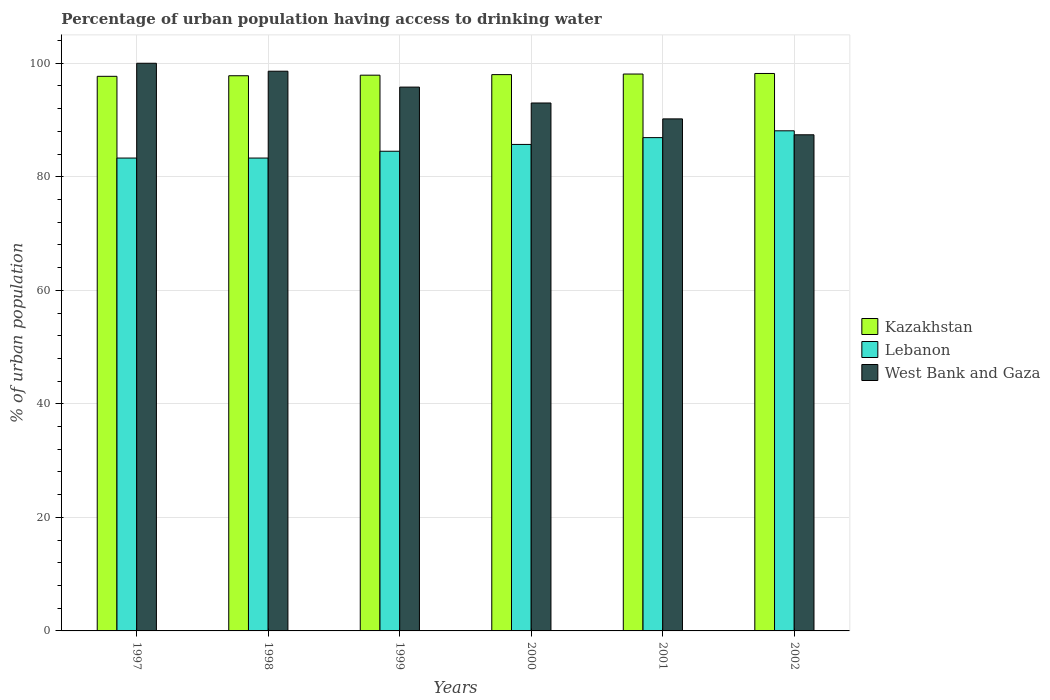Are the number of bars per tick equal to the number of legend labels?
Your answer should be compact. Yes. Are the number of bars on each tick of the X-axis equal?
Offer a terse response. Yes. How many bars are there on the 5th tick from the left?
Keep it short and to the point. 3. What is the label of the 4th group of bars from the left?
Ensure brevity in your answer.  2000. In how many cases, is the number of bars for a given year not equal to the number of legend labels?
Provide a short and direct response. 0. What is the percentage of urban population having access to drinking water in Lebanon in 2000?
Keep it short and to the point. 85.7. Across all years, what is the maximum percentage of urban population having access to drinking water in West Bank and Gaza?
Your answer should be compact. 100. Across all years, what is the minimum percentage of urban population having access to drinking water in Lebanon?
Your answer should be compact. 83.3. In which year was the percentage of urban population having access to drinking water in Lebanon maximum?
Ensure brevity in your answer.  2002. In which year was the percentage of urban population having access to drinking water in Kazakhstan minimum?
Your answer should be compact. 1997. What is the total percentage of urban population having access to drinking water in Kazakhstan in the graph?
Provide a short and direct response. 587.7. What is the difference between the percentage of urban population having access to drinking water in Kazakhstan in 2001 and that in 2002?
Your answer should be very brief. -0.1. What is the average percentage of urban population having access to drinking water in Kazakhstan per year?
Provide a short and direct response. 97.95. In the year 1999, what is the difference between the percentage of urban population having access to drinking water in Lebanon and percentage of urban population having access to drinking water in West Bank and Gaza?
Your response must be concise. -11.3. In how many years, is the percentage of urban population having access to drinking water in Kazakhstan greater than 100 %?
Keep it short and to the point. 0. What is the ratio of the percentage of urban population having access to drinking water in Kazakhstan in 2001 to that in 2002?
Provide a short and direct response. 1. Is the percentage of urban population having access to drinking water in West Bank and Gaza in 1999 less than that in 2002?
Keep it short and to the point. No. Is the difference between the percentage of urban population having access to drinking water in Lebanon in 1999 and 2000 greater than the difference between the percentage of urban population having access to drinking water in West Bank and Gaza in 1999 and 2000?
Your answer should be compact. No. What is the difference between the highest and the second highest percentage of urban population having access to drinking water in Kazakhstan?
Give a very brief answer. 0.1. What is the difference between the highest and the lowest percentage of urban population having access to drinking water in Kazakhstan?
Offer a terse response. 0.5. In how many years, is the percentage of urban population having access to drinking water in Kazakhstan greater than the average percentage of urban population having access to drinking water in Kazakhstan taken over all years?
Make the answer very short. 3. What does the 2nd bar from the left in 1998 represents?
Ensure brevity in your answer.  Lebanon. What does the 2nd bar from the right in 1998 represents?
Provide a succinct answer. Lebanon. Is it the case that in every year, the sum of the percentage of urban population having access to drinking water in Lebanon and percentage of urban population having access to drinking water in Kazakhstan is greater than the percentage of urban population having access to drinking water in West Bank and Gaza?
Offer a very short reply. Yes. How many bars are there?
Ensure brevity in your answer.  18. How many years are there in the graph?
Give a very brief answer. 6. Does the graph contain any zero values?
Provide a succinct answer. No. Does the graph contain grids?
Keep it short and to the point. Yes. Where does the legend appear in the graph?
Keep it short and to the point. Center right. How are the legend labels stacked?
Your answer should be compact. Vertical. What is the title of the graph?
Make the answer very short. Percentage of urban population having access to drinking water. What is the label or title of the Y-axis?
Your answer should be very brief. % of urban population. What is the % of urban population of Kazakhstan in 1997?
Your response must be concise. 97.7. What is the % of urban population in Lebanon in 1997?
Your response must be concise. 83.3. What is the % of urban population of West Bank and Gaza in 1997?
Ensure brevity in your answer.  100. What is the % of urban population in Kazakhstan in 1998?
Your response must be concise. 97.8. What is the % of urban population of Lebanon in 1998?
Your answer should be compact. 83.3. What is the % of urban population in West Bank and Gaza in 1998?
Make the answer very short. 98.6. What is the % of urban population in Kazakhstan in 1999?
Provide a short and direct response. 97.9. What is the % of urban population of Lebanon in 1999?
Your answer should be compact. 84.5. What is the % of urban population of West Bank and Gaza in 1999?
Give a very brief answer. 95.8. What is the % of urban population in Kazakhstan in 2000?
Offer a terse response. 98. What is the % of urban population of Lebanon in 2000?
Provide a short and direct response. 85.7. What is the % of urban population of West Bank and Gaza in 2000?
Your answer should be compact. 93. What is the % of urban population of Kazakhstan in 2001?
Ensure brevity in your answer.  98.1. What is the % of urban population of Lebanon in 2001?
Keep it short and to the point. 86.9. What is the % of urban population in West Bank and Gaza in 2001?
Provide a succinct answer. 90.2. What is the % of urban population in Kazakhstan in 2002?
Your response must be concise. 98.2. What is the % of urban population of Lebanon in 2002?
Make the answer very short. 88.1. What is the % of urban population of West Bank and Gaza in 2002?
Give a very brief answer. 87.4. Across all years, what is the maximum % of urban population in Kazakhstan?
Provide a short and direct response. 98.2. Across all years, what is the maximum % of urban population of Lebanon?
Give a very brief answer. 88.1. Across all years, what is the minimum % of urban population in Kazakhstan?
Offer a terse response. 97.7. Across all years, what is the minimum % of urban population of Lebanon?
Provide a succinct answer. 83.3. Across all years, what is the minimum % of urban population of West Bank and Gaza?
Your response must be concise. 87.4. What is the total % of urban population of Kazakhstan in the graph?
Ensure brevity in your answer.  587.7. What is the total % of urban population of Lebanon in the graph?
Give a very brief answer. 511.8. What is the total % of urban population of West Bank and Gaza in the graph?
Provide a short and direct response. 565. What is the difference between the % of urban population of Kazakhstan in 1997 and that in 1998?
Offer a terse response. -0.1. What is the difference between the % of urban population in Lebanon in 1997 and that in 1998?
Provide a short and direct response. 0. What is the difference between the % of urban population in West Bank and Gaza in 1997 and that in 1998?
Your response must be concise. 1.4. What is the difference between the % of urban population in Lebanon in 1997 and that in 1999?
Offer a terse response. -1.2. What is the difference between the % of urban population of Kazakhstan in 1997 and that in 2000?
Keep it short and to the point. -0.3. What is the difference between the % of urban population of West Bank and Gaza in 1998 and that in 1999?
Provide a short and direct response. 2.8. What is the difference between the % of urban population of Kazakhstan in 1998 and that in 2002?
Give a very brief answer. -0.4. What is the difference between the % of urban population of Lebanon in 1998 and that in 2002?
Provide a succinct answer. -4.8. What is the difference between the % of urban population in Kazakhstan in 1999 and that in 2000?
Make the answer very short. -0.1. What is the difference between the % of urban population of Lebanon in 1999 and that in 2000?
Offer a terse response. -1.2. What is the difference between the % of urban population in West Bank and Gaza in 1999 and that in 2000?
Provide a succinct answer. 2.8. What is the difference between the % of urban population of Kazakhstan in 1999 and that in 2001?
Your response must be concise. -0.2. What is the difference between the % of urban population in Kazakhstan in 1999 and that in 2002?
Offer a very short reply. -0.3. What is the difference between the % of urban population in West Bank and Gaza in 1999 and that in 2002?
Offer a very short reply. 8.4. What is the difference between the % of urban population in Lebanon in 2000 and that in 2001?
Give a very brief answer. -1.2. What is the difference between the % of urban population in Kazakhstan in 2000 and that in 2002?
Your response must be concise. -0.2. What is the difference between the % of urban population of Lebanon in 2000 and that in 2002?
Offer a terse response. -2.4. What is the difference between the % of urban population in Kazakhstan in 2001 and that in 2002?
Provide a succinct answer. -0.1. What is the difference between the % of urban population in Lebanon in 1997 and the % of urban population in West Bank and Gaza in 1998?
Keep it short and to the point. -15.3. What is the difference between the % of urban population of Lebanon in 1997 and the % of urban population of West Bank and Gaza in 1999?
Ensure brevity in your answer.  -12.5. What is the difference between the % of urban population in Kazakhstan in 1997 and the % of urban population in West Bank and Gaza in 2000?
Your answer should be very brief. 4.7. What is the difference between the % of urban population in Kazakhstan in 1997 and the % of urban population in Lebanon in 2001?
Give a very brief answer. 10.8. What is the difference between the % of urban population in Kazakhstan in 1997 and the % of urban population in West Bank and Gaza in 2001?
Your answer should be compact. 7.5. What is the difference between the % of urban population in Lebanon in 1997 and the % of urban population in West Bank and Gaza in 2001?
Ensure brevity in your answer.  -6.9. What is the difference between the % of urban population of Kazakhstan in 1997 and the % of urban population of Lebanon in 2002?
Keep it short and to the point. 9.6. What is the difference between the % of urban population in Kazakhstan in 1997 and the % of urban population in West Bank and Gaza in 2002?
Ensure brevity in your answer.  10.3. What is the difference between the % of urban population of Lebanon in 1997 and the % of urban population of West Bank and Gaza in 2002?
Ensure brevity in your answer.  -4.1. What is the difference between the % of urban population in Kazakhstan in 1998 and the % of urban population in West Bank and Gaza in 2001?
Offer a very short reply. 7.6. What is the difference between the % of urban population of Lebanon in 1998 and the % of urban population of West Bank and Gaza in 2002?
Make the answer very short. -4.1. What is the difference between the % of urban population of Kazakhstan in 1999 and the % of urban population of West Bank and Gaza in 2000?
Provide a succinct answer. 4.9. What is the difference between the % of urban population of Lebanon in 1999 and the % of urban population of West Bank and Gaza in 2000?
Make the answer very short. -8.5. What is the difference between the % of urban population of Kazakhstan in 1999 and the % of urban population of Lebanon in 2001?
Offer a terse response. 11. What is the difference between the % of urban population in Kazakhstan in 1999 and the % of urban population in West Bank and Gaza in 2001?
Keep it short and to the point. 7.7. What is the difference between the % of urban population of Lebanon in 1999 and the % of urban population of West Bank and Gaza in 2002?
Your answer should be compact. -2.9. What is the difference between the % of urban population in Lebanon in 2000 and the % of urban population in West Bank and Gaza in 2001?
Offer a very short reply. -4.5. What is the difference between the % of urban population of Kazakhstan in 2000 and the % of urban population of Lebanon in 2002?
Offer a very short reply. 9.9. What is the difference between the % of urban population in Kazakhstan in 2000 and the % of urban population in West Bank and Gaza in 2002?
Make the answer very short. 10.6. What is the difference between the % of urban population of Lebanon in 2001 and the % of urban population of West Bank and Gaza in 2002?
Your answer should be compact. -0.5. What is the average % of urban population in Kazakhstan per year?
Offer a very short reply. 97.95. What is the average % of urban population in Lebanon per year?
Your answer should be very brief. 85.3. What is the average % of urban population in West Bank and Gaza per year?
Provide a succinct answer. 94.17. In the year 1997, what is the difference between the % of urban population of Kazakhstan and % of urban population of Lebanon?
Your response must be concise. 14.4. In the year 1997, what is the difference between the % of urban population in Lebanon and % of urban population in West Bank and Gaza?
Your answer should be compact. -16.7. In the year 1998, what is the difference between the % of urban population of Kazakhstan and % of urban population of Lebanon?
Provide a succinct answer. 14.5. In the year 1998, what is the difference between the % of urban population in Lebanon and % of urban population in West Bank and Gaza?
Ensure brevity in your answer.  -15.3. In the year 1999, what is the difference between the % of urban population of Kazakhstan and % of urban population of Lebanon?
Give a very brief answer. 13.4. In the year 1999, what is the difference between the % of urban population in Kazakhstan and % of urban population in West Bank and Gaza?
Provide a short and direct response. 2.1. In the year 1999, what is the difference between the % of urban population of Lebanon and % of urban population of West Bank and Gaza?
Ensure brevity in your answer.  -11.3. In the year 2000, what is the difference between the % of urban population in Kazakhstan and % of urban population in Lebanon?
Give a very brief answer. 12.3. In the year 2001, what is the difference between the % of urban population in Kazakhstan and % of urban population in Lebanon?
Provide a succinct answer. 11.2. In the year 2001, what is the difference between the % of urban population of Lebanon and % of urban population of West Bank and Gaza?
Ensure brevity in your answer.  -3.3. In the year 2002, what is the difference between the % of urban population in Kazakhstan and % of urban population in Lebanon?
Offer a very short reply. 10.1. In the year 2002, what is the difference between the % of urban population of Lebanon and % of urban population of West Bank and Gaza?
Ensure brevity in your answer.  0.7. What is the ratio of the % of urban population of Lebanon in 1997 to that in 1998?
Make the answer very short. 1. What is the ratio of the % of urban population in West Bank and Gaza in 1997 to that in 1998?
Give a very brief answer. 1.01. What is the ratio of the % of urban population in Kazakhstan in 1997 to that in 1999?
Provide a short and direct response. 1. What is the ratio of the % of urban population of Lebanon in 1997 to that in 1999?
Give a very brief answer. 0.99. What is the ratio of the % of urban population in West Bank and Gaza in 1997 to that in 1999?
Offer a very short reply. 1.04. What is the ratio of the % of urban population of Lebanon in 1997 to that in 2000?
Offer a very short reply. 0.97. What is the ratio of the % of urban population of West Bank and Gaza in 1997 to that in 2000?
Your answer should be very brief. 1.08. What is the ratio of the % of urban population in Kazakhstan in 1997 to that in 2001?
Give a very brief answer. 1. What is the ratio of the % of urban population of Lebanon in 1997 to that in 2001?
Offer a very short reply. 0.96. What is the ratio of the % of urban population in West Bank and Gaza in 1997 to that in 2001?
Provide a succinct answer. 1.11. What is the ratio of the % of urban population of Kazakhstan in 1997 to that in 2002?
Give a very brief answer. 0.99. What is the ratio of the % of urban population in Lebanon in 1997 to that in 2002?
Offer a very short reply. 0.95. What is the ratio of the % of urban population of West Bank and Gaza in 1997 to that in 2002?
Your answer should be very brief. 1.14. What is the ratio of the % of urban population in Lebanon in 1998 to that in 1999?
Offer a terse response. 0.99. What is the ratio of the % of urban population in West Bank and Gaza in 1998 to that in 1999?
Offer a very short reply. 1.03. What is the ratio of the % of urban population of Kazakhstan in 1998 to that in 2000?
Your answer should be very brief. 1. What is the ratio of the % of urban population in Lebanon in 1998 to that in 2000?
Offer a terse response. 0.97. What is the ratio of the % of urban population in West Bank and Gaza in 1998 to that in 2000?
Give a very brief answer. 1.06. What is the ratio of the % of urban population in Lebanon in 1998 to that in 2001?
Make the answer very short. 0.96. What is the ratio of the % of urban population of West Bank and Gaza in 1998 to that in 2001?
Your response must be concise. 1.09. What is the ratio of the % of urban population of Kazakhstan in 1998 to that in 2002?
Make the answer very short. 1. What is the ratio of the % of urban population of Lebanon in 1998 to that in 2002?
Your answer should be very brief. 0.95. What is the ratio of the % of urban population in West Bank and Gaza in 1998 to that in 2002?
Make the answer very short. 1.13. What is the ratio of the % of urban population of Kazakhstan in 1999 to that in 2000?
Offer a very short reply. 1. What is the ratio of the % of urban population of West Bank and Gaza in 1999 to that in 2000?
Offer a terse response. 1.03. What is the ratio of the % of urban population of Lebanon in 1999 to that in 2001?
Ensure brevity in your answer.  0.97. What is the ratio of the % of urban population in West Bank and Gaza in 1999 to that in 2001?
Keep it short and to the point. 1.06. What is the ratio of the % of urban population of Kazakhstan in 1999 to that in 2002?
Keep it short and to the point. 1. What is the ratio of the % of urban population of Lebanon in 1999 to that in 2002?
Provide a succinct answer. 0.96. What is the ratio of the % of urban population in West Bank and Gaza in 1999 to that in 2002?
Keep it short and to the point. 1.1. What is the ratio of the % of urban population of Lebanon in 2000 to that in 2001?
Your answer should be compact. 0.99. What is the ratio of the % of urban population in West Bank and Gaza in 2000 to that in 2001?
Keep it short and to the point. 1.03. What is the ratio of the % of urban population of Lebanon in 2000 to that in 2002?
Make the answer very short. 0.97. What is the ratio of the % of urban population in West Bank and Gaza in 2000 to that in 2002?
Offer a terse response. 1.06. What is the ratio of the % of urban population of Kazakhstan in 2001 to that in 2002?
Ensure brevity in your answer.  1. What is the ratio of the % of urban population of Lebanon in 2001 to that in 2002?
Your answer should be very brief. 0.99. What is the ratio of the % of urban population in West Bank and Gaza in 2001 to that in 2002?
Keep it short and to the point. 1.03. What is the difference between the highest and the second highest % of urban population of Kazakhstan?
Provide a succinct answer. 0.1. What is the difference between the highest and the second highest % of urban population of Lebanon?
Offer a very short reply. 1.2. What is the difference between the highest and the lowest % of urban population in West Bank and Gaza?
Give a very brief answer. 12.6. 